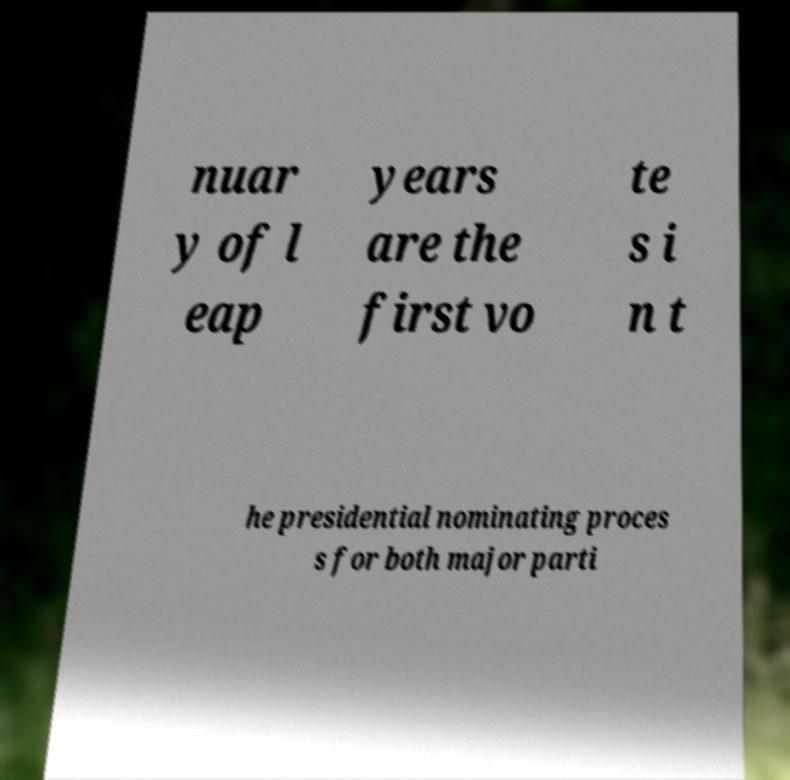Please read and relay the text visible in this image. What does it say? nuar y of l eap years are the first vo te s i n t he presidential nominating proces s for both major parti 